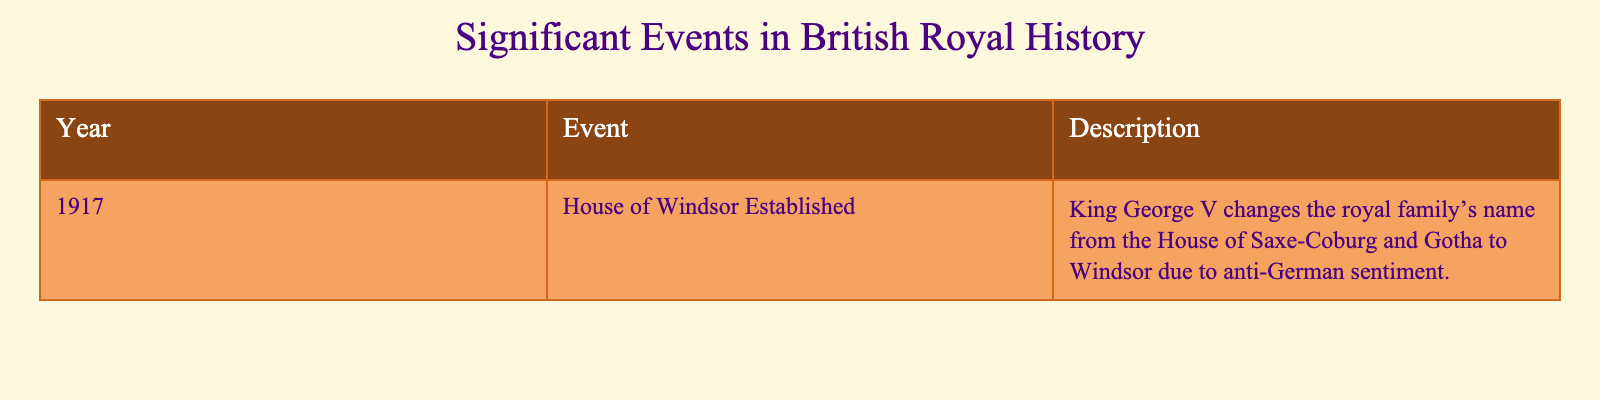What significant event occurred in 1917? The table directly states that in 1917, the House of Windsor was established.
Answer: House of Windsor Established Why did King George V change the royal family’s name in 1917? The description provided in the table indicates that it was due to anti-German sentiment.
Answer: Anti-German sentiment Is there a significant event listed for the year 1916? The table only contains data for the year 1917, and there is no mention of any events in 1916. Therefore, this statement is true.
Answer: True What can be inferred about the royal family's name prior to 1917? Since the table mentions the name was changed from the House of Saxe-Coburg and Gotha to Windsor in 1917, we can infer that the royal family was previously known by the former name.
Answer: House of Saxe-Coburg and Gotha How many significant events in British royal history are listed in the table? The table shows only one significant event, which is from the year 1917.
Answer: One Did the establishment of the House of Windsor have any connection to world events at the time? Given that the name change was a response to anti-German sentiment, it can be deduced that it was influenced by the context of World War I during that era.
Answer: Yes 